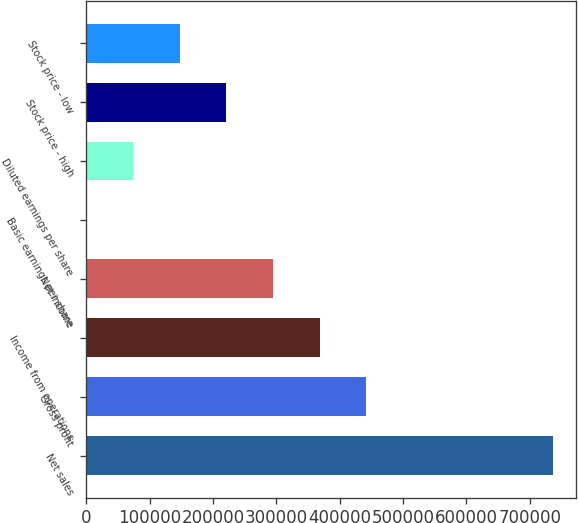Convert chart. <chart><loc_0><loc_0><loc_500><loc_500><bar_chart><fcel>Net sales<fcel>Gross profit<fcel>Income from operations<fcel>Net income<fcel>Basic earnings per share<fcel>Diluted earnings per share<fcel>Stock price - high<fcel>Stock price - low<nl><fcel>736579<fcel>441948<fcel>368290<fcel>294632<fcel>0.63<fcel>73658.5<fcel>220974<fcel>147316<nl></chart> 